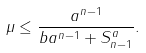<formula> <loc_0><loc_0><loc_500><loc_500>\mu \leq \frac { a ^ { n - 1 } } { b a ^ { n - 1 } + S _ { n - 1 } ^ { a } } .</formula> 